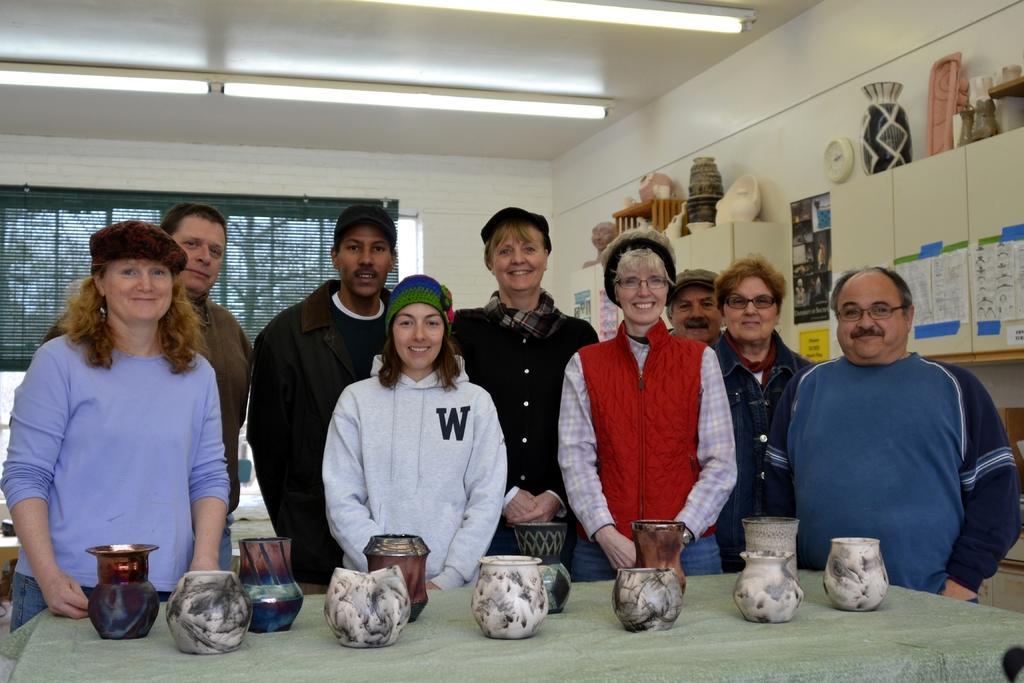In one or two sentences, can you explain what this image depicts? This image consists of many people. In the front, there is a table covered with a cloth on which, there are many bowls made up of ceramics. On the right, there are cupboards on which there are many objects kept made up of ceramics. At the top, there is a roof along with the lights. In the background, there is a window along with window blind. 